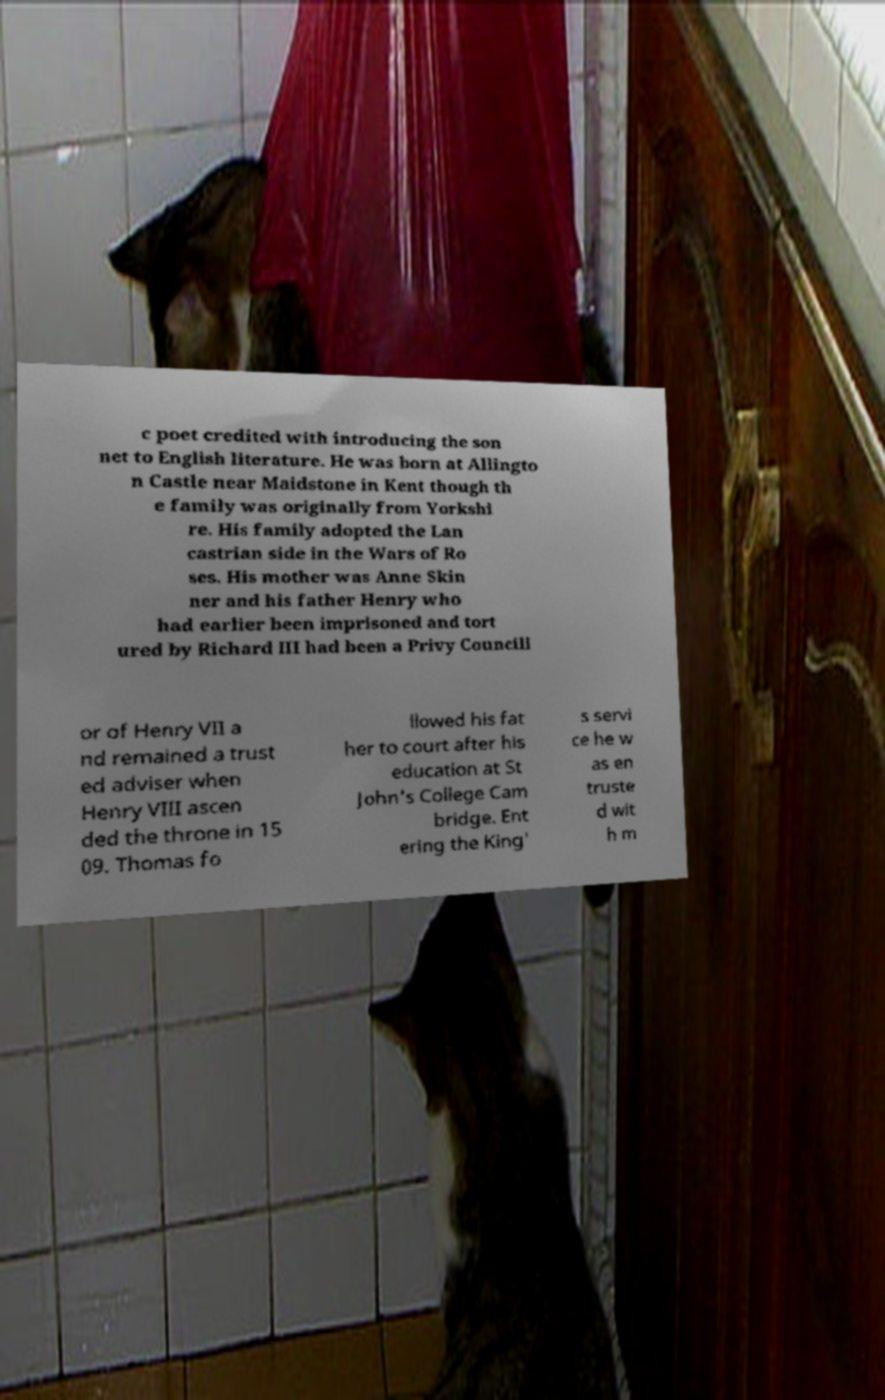Can you accurately transcribe the text from the provided image for me? c poet credited with introducing the son net to English literature. He was born at Allingto n Castle near Maidstone in Kent though th e family was originally from Yorkshi re. His family adopted the Lan castrian side in the Wars of Ro ses. His mother was Anne Skin ner and his father Henry who had earlier been imprisoned and tort ured by Richard III had been a Privy Councill or of Henry VII a nd remained a trust ed adviser when Henry VIII ascen ded the throne in 15 09. Thomas fo llowed his fat her to court after his education at St John's College Cam bridge. Ent ering the King' s servi ce he w as en truste d wit h m 